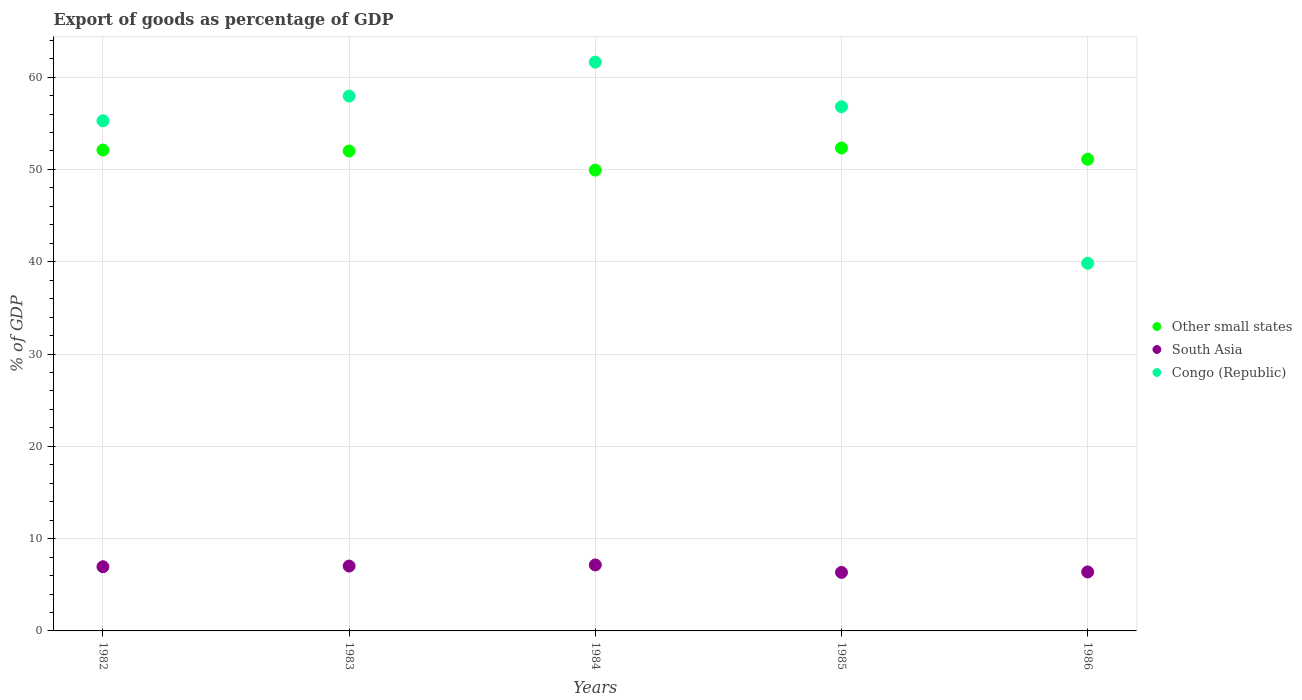How many different coloured dotlines are there?
Your answer should be compact. 3. What is the export of goods as percentage of GDP in Other small states in 1982?
Provide a succinct answer. 52.1. Across all years, what is the maximum export of goods as percentage of GDP in Other small states?
Offer a very short reply. 52.32. Across all years, what is the minimum export of goods as percentage of GDP in Congo (Republic)?
Give a very brief answer. 39.83. What is the total export of goods as percentage of GDP in Congo (Republic) in the graph?
Your answer should be compact. 271.46. What is the difference between the export of goods as percentage of GDP in South Asia in 1983 and that in 1984?
Make the answer very short. -0.12. What is the difference between the export of goods as percentage of GDP in South Asia in 1985 and the export of goods as percentage of GDP in Congo (Republic) in 1983?
Make the answer very short. -51.6. What is the average export of goods as percentage of GDP in Congo (Republic) per year?
Make the answer very short. 54.29. In the year 1984, what is the difference between the export of goods as percentage of GDP in South Asia and export of goods as percentage of GDP in Other small states?
Your answer should be compact. -42.77. What is the ratio of the export of goods as percentage of GDP in Other small states in 1982 to that in 1985?
Offer a terse response. 1. Is the export of goods as percentage of GDP in Other small states in 1983 less than that in 1985?
Offer a terse response. Yes. Is the difference between the export of goods as percentage of GDP in South Asia in 1983 and 1986 greater than the difference between the export of goods as percentage of GDP in Other small states in 1983 and 1986?
Ensure brevity in your answer.  No. What is the difference between the highest and the second highest export of goods as percentage of GDP in Other small states?
Your response must be concise. 0.22. What is the difference between the highest and the lowest export of goods as percentage of GDP in Other small states?
Offer a terse response. 2.4. In how many years, is the export of goods as percentage of GDP in South Asia greater than the average export of goods as percentage of GDP in South Asia taken over all years?
Make the answer very short. 3. Is it the case that in every year, the sum of the export of goods as percentage of GDP in Other small states and export of goods as percentage of GDP in Congo (Republic)  is greater than the export of goods as percentage of GDP in South Asia?
Provide a short and direct response. Yes. Is the export of goods as percentage of GDP in Congo (Republic) strictly greater than the export of goods as percentage of GDP in Other small states over the years?
Provide a short and direct response. No. How many dotlines are there?
Make the answer very short. 3. What is the difference between two consecutive major ticks on the Y-axis?
Your answer should be compact. 10. Are the values on the major ticks of Y-axis written in scientific E-notation?
Your response must be concise. No. Does the graph contain grids?
Your answer should be very brief. Yes. How many legend labels are there?
Make the answer very short. 3. How are the legend labels stacked?
Offer a terse response. Vertical. What is the title of the graph?
Offer a very short reply. Export of goods as percentage of GDP. What is the label or title of the X-axis?
Your response must be concise. Years. What is the label or title of the Y-axis?
Offer a terse response. % of GDP. What is the % of GDP in Other small states in 1982?
Provide a succinct answer. 52.1. What is the % of GDP in South Asia in 1982?
Provide a short and direct response. 6.95. What is the % of GDP in Congo (Republic) in 1982?
Your answer should be compact. 55.27. What is the % of GDP in Other small states in 1983?
Your answer should be very brief. 51.99. What is the % of GDP of South Asia in 1983?
Your answer should be very brief. 7.03. What is the % of GDP in Congo (Republic) in 1983?
Your answer should be very brief. 57.95. What is the % of GDP in Other small states in 1984?
Your answer should be very brief. 49.92. What is the % of GDP of South Asia in 1984?
Provide a short and direct response. 7.15. What is the % of GDP in Congo (Republic) in 1984?
Your answer should be compact. 61.63. What is the % of GDP in Other small states in 1985?
Your response must be concise. 52.32. What is the % of GDP of South Asia in 1985?
Keep it short and to the point. 6.34. What is the % of GDP of Congo (Republic) in 1985?
Keep it short and to the point. 56.79. What is the % of GDP of Other small states in 1986?
Offer a terse response. 51.1. What is the % of GDP of South Asia in 1986?
Offer a very short reply. 6.39. What is the % of GDP of Congo (Republic) in 1986?
Keep it short and to the point. 39.83. Across all years, what is the maximum % of GDP of Other small states?
Your answer should be compact. 52.32. Across all years, what is the maximum % of GDP of South Asia?
Your answer should be very brief. 7.15. Across all years, what is the maximum % of GDP in Congo (Republic)?
Ensure brevity in your answer.  61.63. Across all years, what is the minimum % of GDP of Other small states?
Make the answer very short. 49.92. Across all years, what is the minimum % of GDP in South Asia?
Keep it short and to the point. 6.34. Across all years, what is the minimum % of GDP of Congo (Republic)?
Offer a terse response. 39.83. What is the total % of GDP of Other small states in the graph?
Give a very brief answer. 257.43. What is the total % of GDP in South Asia in the graph?
Offer a very short reply. 33.86. What is the total % of GDP of Congo (Republic) in the graph?
Ensure brevity in your answer.  271.46. What is the difference between the % of GDP in Other small states in 1982 and that in 1983?
Your response must be concise. 0.11. What is the difference between the % of GDP of South Asia in 1982 and that in 1983?
Provide a short and direct response. -0.07. What is the difference between the % of GDP in Congo (Republic) in 1982 and that in 1983?
Provide a succinct answer. -2.68. What is the difference between the % of GDP of Other small states in 1982 and that in 1984?
Keep it short and to the point. 2.18. What is the difference between the % of GDP in South Asia in 1982 and that in 1984?
Your response must be concise. -0.19. What is the difference between the % of GDP in Congo (Republic) in 1982 and that in 1984?
Keep it short and to the point. -6.36. What is the difference between the % of GDP of Other small states in 1982 and that in 1985?
Your answer should be very brief. -0.22. What is the difference between the % of GDP in South Asia in 1982 and that in 1985?
Ensure brevity in your answer.  0.61. What is the difference between the % of GDP in Congo (Republic) in 1982 and that in 1985?
Your answer should be compact. -1.52. What is the difference between the % of GDP of South Asia in 1982 and that in 1986?
Provide a succinct answer. 0.56. What is the difference between the % of GDP in Congo (Republic) in 1982 and that in 1986?
Ensure brevity in your answer.  15.43. What is the difference between the % of GDP of Other small states in 1983 and that in 1984?
Make the answer very short. 2.07. What is the difference between the % of GDP in South Asia in 1983 and that in 1984?
Your answer should be very brief. -0.12. What is the difference between the % of GDP of Congo (Republic) in 1983 and that in 1984?
Keep it short and to the point. -3.68. What is the difference between the % of GDP of Other small states in 1983 and that in 1985?
Offer a very short reply. -0.33. What is the difference between the % of GDP in South Asia in 1983 and that in 1985?
Your answer should be compact. 0.69. What is the difference between the % of GDP of Congo (Republic) in 1983 and that in 1985?
Ensure brevity in your answer.  1.16. What is the difference between the % of GDP in Other small states in 1983 and that in 1986?
Offer a very short reply. 0.89. What is the difference between the % of GDP in South Asia in 1983 and that in 1986?
Make the answer very short. 0.64. What is the difference between the % of GDP of Congo (Republic) in 1983 and that in 1986?
Your answer should be very brief. 18.11. What is the difference between the % of GDP of Other small states in 1984 and that in 1985?
Offer a very short reply. -2.4. What is the difference between the % of GDP in South Asia in 1984 and that in 1985?
Your response must be concise. 0.81. What is the difference between the % of GDP of Congo (Republic) in 1984 and that in 1985?
Give a very brief answer. 4.84. What is the difference between the % of GDP of Other small states in 1984 and that in 1986?
Ensure brevity in your answer.  -1.18. What is the difference between the % of GDP of South Asia in 1984 and that in 1986?
Your answer should be compact. 0.76. What is the difference between the % of GDP of Congo (Republic) in 1984 and that in 1986?
Ensure brevity in your answer.  21.79. What is the difference between the % of GDP of Other small states in 1985 and that in 1986?
Ensure brevity in your answer.  1.22. What is the difference between the % of GDP of South Asia in 1985 and that in 1986?
Your answer should be compact. -0.05. What is the difference between the % of GDP of Congo (Republic) in 1985 and that in 1986?
Your answer should be very brief. 16.95. What is the difference between the % of GDP in Other small states in 1982 and the % of GDP in South Asia in 1983?
Offer a terse response. 45.07. What is the difference between the % of GDP in Other small states in 1982 and the % of GDP in Congo (Republic) in 1983?
Provide a succinct answer. -5.85. What is the difference between the % of GDP of South Asia in 1982 and the % of GDP of Congo (Republic) in 1983?
Make the answer very short. -50.99. What is the difference between the % of GDP in Other small states in 1982 and the % of GDP in South Asia in 1984?
Your answer should be very brief. 44.95. What is the difference between the % of GDP in Other small states in 1982 and the % of GDP in Congo (Republic) in 1984?
Give a very brief answer. -9.53. What is the difference between the % of GDP of South Asia in 1982 and the % of GDP of Congo (Republic) in 1984?
Offer a very short reply. -54.67. What is the difference between the % of GDP in Other small states in 1982 and the % of GDP in South Asia in 1985?
Provide a short and direct response. 45.76. What is the difference between the % of GDP in Other small states in 1982 and the % of GDP in Congo (Republic) in 1985?
Ensure brevity in your answer.  -4.69. What is the difference between the % of GDP of South Asia in 1982 and the % of GDP of Congo (Republic) in 1985?
Your answer should be compact. -49.83. What is the difference between the % of GDP of Other small states in 1982 and the % of GDP of South Asia in 1986?
Give a very brief answer. 45.71. What is the difference between the % of GDP of Other small states in 1982 and the % of GDP of Congo (Republic) in 1986?
Offer a terse response. 12.27. What is the difference between the % of GDP of South Asia in 1982 and the % of GDP of Congo (Republic) in 1986?
Ensure brevity in your answer.  -32.88. What is the difference between the % of GDP in Other small states in 1983 and the % of GDP in South Asia in 1984?
Keep it short and to the point. 44.84. What is the difference between the % of GDP in Other small states in 1983 and the % of GDP in Congo (Republic) in 1984?
Your answer should be compact. -9.64. What is the difference between the % of GDP in South Asia in 1983 and the % of GDP in Congo (Republic) in 1984?
Offer a very short reply. -54.6. What is the difference between the % of GDP of Other small states in 1983 and the % of GDP of South Asia in 1985?
Keep it short and to the point. 45.65. What is the difference between the % of GDP in Other small states in 1983 and the % of GDP in Congo (Republic) in 1985?
Offer a very short reply. -4.8. What is the difference between the % of GDP in South Asia in 1983 and the % of GDP in Congo (Republic) in 1985?
Your answer should be compact. -49.76. What is the difference between the % of GDP in Other small states in 1983 and the % of GDP in South Asia in 1986?
Offer a terse response. 45.6. What is the difference between the % of GDP of Other small states in 1983 and the % of GDP of Congo (Republic) in 1986?
Provide a succinct answer. 12.16. What is the difference between the % of GDP of South Asia in 1983 and the % of GDP of Congo (Republic) in 1986?
Make the answer very short. -32.81. What is the difference between the % of GDP of Other small states in 1984 and the % of GDP of South Asia in 1985?
Offer a terse response. 43.58. What is the difference between the % of GDP of Other small states in 1984 and the % of GDP of Congo (Republic) in 1985?
Provide a short and direct response. -6.86. What is the difference between the % of GDP of South Asia in 1984 and the % of GDP of Congo (Republic) in 1985?
Make the answer very short. -49.64. What is the difference between the % of GDP in Other small states in 1984 and the % of GDP in South Asia in 1986?
Your response must be concise. 43.53. What is the difference between the % of GDP in Other small states in 1984 and the % of GDP in Congo (Republic) in 1986?
Give a very brief answer. 10.09. What is the difference between the % of GDP in South Asia in 1984 and the % of GDP in Congo (Republic) in 1986?
Your answer should be compact. -32.68. What is the difference between the % of GDP in Other small states in 1985 and the % of GDP in South Asia in 1986?
Your response must be concise. 45.93. What is the difference between the % of GDP of Other small states in 1985 and the % of GDP of Congo (Republic) in 1986?
Your answer should be compact. 12.49. What is the difference between the % of GDP in South Asia in 1985 and the % of GDP in Congo (Republic) in 1986?
Your answer should be very brief. -33.49. What is the average % of GDP in Other small states per year?
Ensure brevity in your answer.  51.49. What is the average % of GDP of South Asia per year?
Ensure brevity in your answer.  6.77. What is the average % of GDP in Congo (Republic) per year?
Offer a terse response. 54.29. In the year 1982, what is the difference between the % of GDP of Other small states and % of GDP of South Asia?
Your answer should be very brief. 45.15. In the year 1982, what is the difference between the % of GDP in Other small states and % of GDP in Congo (Republic)?
Offer a terse response. -3.17. In the year 1982, what is the difference between the % of GDP in South Asia and % of GDP in Congo (Republic)?
Make the answer very short. -48.31. In the year 1983, what is the difference between the % of GDP in Other small states and % of GDP in South Asia?
Ensure brevity in your answer.  44.96. In the year 1983, what is the difference between the % of GDP in Other small states and % of GDP in Congo (Republic)?
Offer a very short reply. -5.95. In the year 1983, what is the difference between the % of GDP in South Asia and % of GDP in Congo (Republic)?
Your answer should be compact. -50.92. In the year 1984, what is the difference between the % of GDP of Other small states and % of GDP of South Asia?
Ensure brevity in your answer.  42.77. In the year 1984, what is the difference between the % of GDP of Other small states and % of GDP of Congo (Republic)?
Make the answer very short. -11.7. In the year 1984, what is the difference between the % of GDP in South Asia and % of GDP in Congo (Republic)?
Offer a terse response. -54.48. In the year 1985, what is the difference between the % of GDP of Other small states and % of GDP of South Asia?
Ensure brevity in your answer.  45.98. In the year 1985, what is the difference between the % of GDP in Other small states and % of GDP in Congo (Republic)?
Your answer should be compact. -4.47. In the year 1985, what is the difference between the % of GDP in South Asia and % of GDP in Congo (Republic)?
Ensure brevity in your answer.  -50.45. In the year 1986, what is the difference between the % of GDP of Other small states and % of GDP of South Asia?
Ensure brevity in your answer.  44.71. In the year 1986, what is the difference between the % of GDP in Other small states and % of GDP in Congo (Republic)?
Your answer should be compact. 11.27. In the year 1986, what is the difference between the % of GDP in South Asia and % of GDP in Congo (Republic)?
Keep it short and to the point. -33.44. What is the ratio of the % of GDP in Other small states in 1982 to that in 1983?
Your response must be concise. 1. What is the ratio of the % of GDP in South Asia in 1982 to that in 1983?
Ensure brevity in your answer.  0.99. What is the ratio of the % of GDP of Congo (Republic) in 1982 to that in 1983?
Provide a short and direct response. 0.95. What is the ratio of the % of GDP in Other small states in 1982 to that in 1984?
Offer a terse response. 1.04. What is the ratio of the % of GDP of South Asia in 1982 to that in 1984?
Give a very brief answer. 0.97. What is the ratio of the % of GDP in Congo (Republic) in 1982 to that in 1984?
Your answer should be compact. 0.9. What is the ratio of the % of GDP in South Asia in 1982 to that in 1985?
Your answer should be compact. 1.1. What is the ratio of the % of GDP of Congo (Republic) in 1982 to that in 1985?
Ensure brevity in your answer.  0.97. What is the ratio of the % of GDP in Other small states in 1982 to that in 1986?
Offer a terse response. 1.02. What is the ratio of the % of GDP in South Asia in 1982 to that in 1986?
Keep it short and to the point. 1.09. What is the ratio of the % of GDP in Congo (Republic) in 1982 to that in 1986?
Your response must be concise. 1.39. What is the ratio of the % of GDP in Other small states in 1983 to that in 1984?
Make the answer very short. 1.04. What is the ratio of the % of GDP of South Asia in 1983 to that in 1984?
Give a very brief answer. 0.98. What is the ratio of the % of GDP in Congo (Republic) in 1983 to that in 1984?
Your answer should be very brief. 0.94. What is the ratio of the % of GDP in Other small states in 1983 to that in 1985?
Your answer should be compact. 0.99. What is the ratio of the % of GDP of South Asia in 1983 to that in 1985?
Ensure brevity in your answer.  1.11. What is the ratio of the % of GDP of Congo (Republic) in 1983 to that in 1985?
Offer a very short reply. 1.02. What is the ratio of the % of GDP of Other small states in 1983 to that in 1986?
Provide a short and direct response. 1.02. What is the ratio of the % of GDP of South Asia in 1983 to that in 1986?
Give a very brief answer. 1.1. What is the ratio of the % of GDP of Congo (Republic) in 1983 to that in 1986?
Provide a succinct answer. 1.45. What is the ratio of the % of GDP of Other small states in 1984 to that in 1985?
Make the answer very short. 0.95. What is the ratio of the % of GDP in South Asia in 1984 to that in 1985?
Ensure brevity in your answer.  1.13. What is the ratio of the % of GDP of Congo (Republic) in 1984 to that in 1985?
Provide a short and direct response. 1.09. What is the ratio of the % of GDP in Other small states in 1984 to that in 1986?
Provide a succinct answer. 0.98. What is the ratio of the % of GDP of South Asia in 1984 to that in 1986?
Offer a very short reply. 1.12. What is the ratio of the % of GDP of Congo (Republic) in 1984 to that in 1986?
Offer a terse response. 1.55. What is the ratio of the % of GDP in Other small states in 1985 to that in 1986?
Your response must be concise. 1.02. What is the ratio of the % of GDP of South Asia in 1985 to that in 1986?
Make the answer very short. 0.99. What is the ratio of the % of GDP of Congo (Republic) in 1985 to that in 1986?
Your answer should be very brief. 1.43. What is the difference between the highest and the second highest % of GDP of Other small states?
Provide a succinct answer. 0.22. What is the difference between the highest and the second highest % of GDP of South Asia?
Offer a terse response. 0.12. What is the difference between the highest and the second highest % of GDP of Congo (Republic)?
Provide a succinct answer. 3.68. What is the difference between the highest and the lowest % of GDP in Other small states?
Your answer should be compact. 2.4. What is the difference between the highest and the lowest % of GDP of South Asia?
Your answer should be compact. 0.81. What is the difference between the highest and the lowest % of GDP in Congo (Republic)?
Provide a short and direct response. 21.79. 